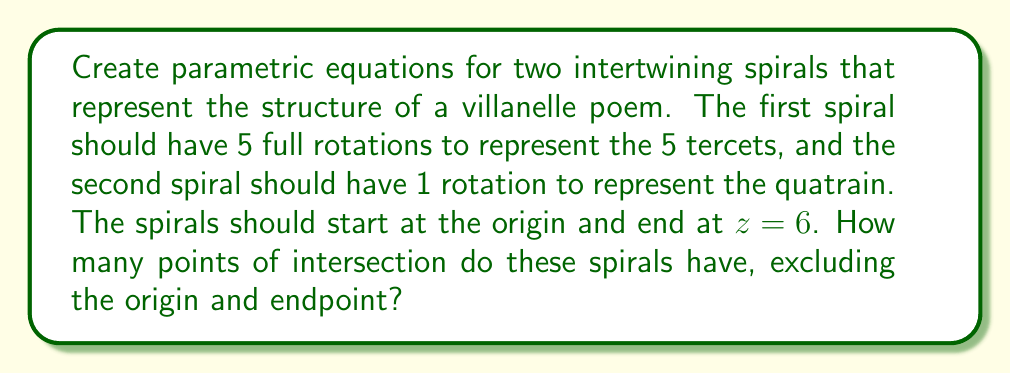What is the answer to this math problem? Let's approach this step-by-step:

1) First, we need to create parametric equations for two spirals. We'll use the following general form:
   $$x = r\cos(\theta)$$
   $$y = r\sin(\theta)$$
   $$z = a\theta$$

   Where $r$ is the radius, $\theta$ is the angle, and $a$ is a constant that determines the pitch of the spiral.

2) For the first spiral (representing the 5 tercets):
   $$x_1 = \cos(5\pi t)$$
   $$y_1 = \sin(5\pi t)$$
   $$z_1 = 6t$$
   Where $0 \leq t \leq 1$

3) For the second spiral (representing the quatrain):
   $$x_2 = \cos(\pi t)$$
   $$y_2 = \sin(\pi t)$$
   $$z_2 = 6t$$
   Where $0 \leq t \leq 1$

4) To find the intersection points, we need to solve:
   $$\cos(5\pi t_1) = \cos(\pi t_2)$$
   $$\sin(5\pi t_1) = \sin(\pi t_2)$$
   $$6t_1 = 6t_2$$

5) From the third equation, we can see that $t_1 = t_2 = t$

6) This means we need to solve:
   $$\cos(5\pi t) = \cos(\pi t)$$
   $$\sin(5\pi t) = \sin(\pi t)$$

7) These equations are satisfied when:
   $$5\pi t = \pi t + 2\pi n$$ or $$5\pi t = -\pi t + 2\pi n$$
   Where $n$ is an integer.

8) Solving these:
   $$t = \frac{n}{2}$$ or $$t = \frac{n}{3}$$

9) Given that $0 < t < 1$, the valid solutions are:
   $t = \frac{1}{3}, \frac{1}{2}, \frac{2}{3}$

10) Therefore, there are 3 intersection points between the spirals, excluding the origin (t = 0) and endpoint (t = 1).
Answer: The two intertwining spirals representing the structure of a villanelle poem have 3 points of intersection, excluding the origin and endpoint. 